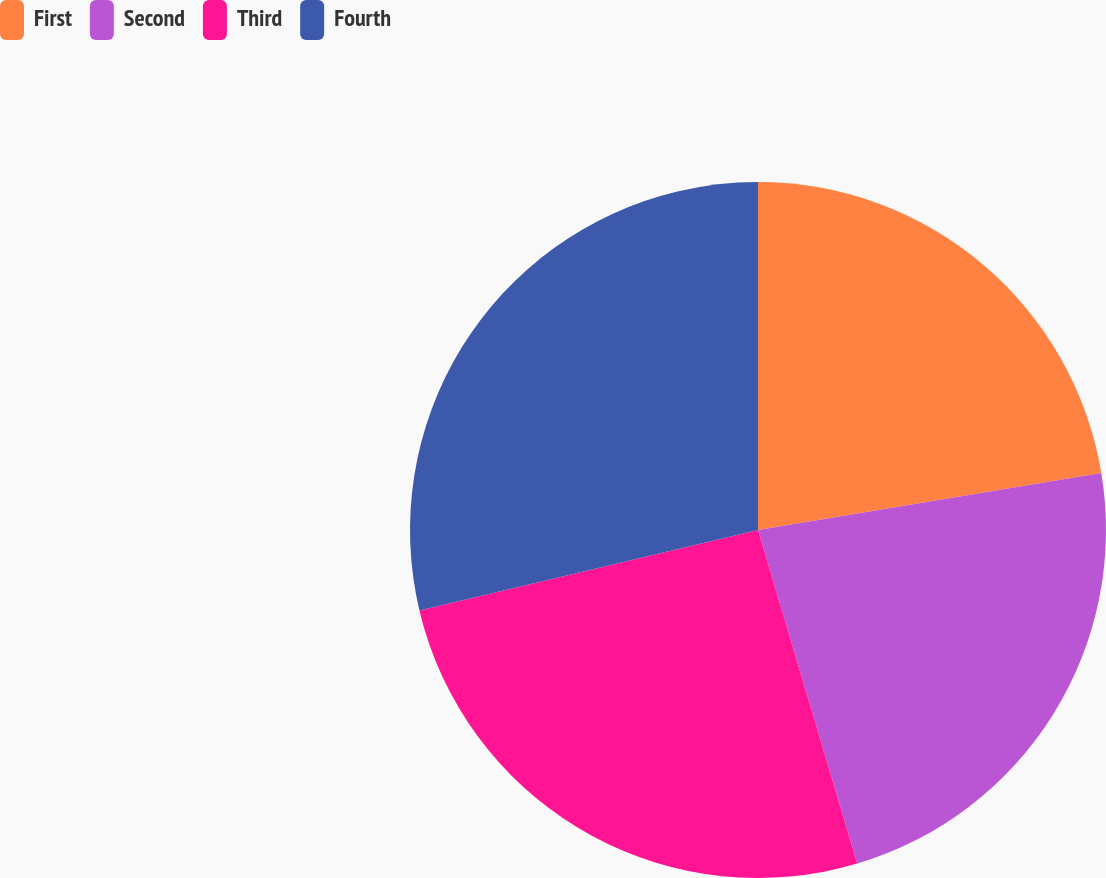Convert chart to OTSL. <chart><loc_0><loc_0><loc_500><loc_500><pie_chart><fcel>First<fcel>Second<fcel>Third<fcel>Fourth<nl><fcel>22.38%<fcel>23.02%<fcel>25.88%<fcel>28.72%<nl></chart> 